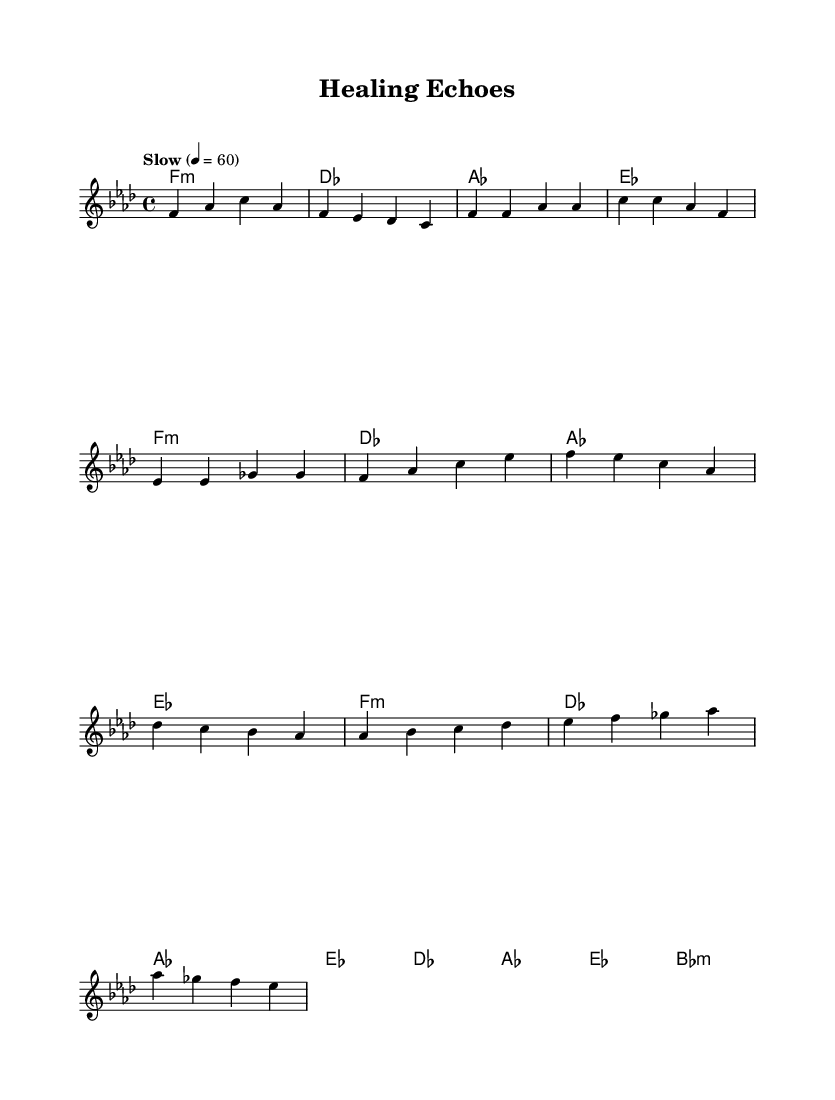What is the key signature of this music? The key signature is indicated by the key signature symbol on the staff. In this case, it is F minor, which has four flats (B, E, A, and D).
Answer: F minor What is the time signature of the piece? The time signature is shown at the beginning of the music; here, it is 4/4, meaning there are four beats per measure, and each quarter note receives one beat.
Answer: 4/4 What is the tempo marking for this piece? The tempo marking indicated at the start of the score says "Slow" and sets the beat at 60 beats per minute. This is a common way to denote a slower pace often found in ballads.
Answer: Slow, 60 How many measures are in the chorus section? By counting the measures in the chorus section of the music shown, we find that there are four measures dedicated to the chorus. This can be determined by identifying the grouping of the notes and their corresponding measures.
Answer: 4 What type of chord is indicated for the intro section? The intro section contains a chord label that indicates "F:min" at the beginning, showing it is a minor chord, which is often characteristic of the mood in soul music.
Answer: F:min What musical pattern is primarily used in the melody? The melody predominantly utilizes a simple repeating rhythmic pattern with quarter notes and can be seen in the first few measures. This reflects a common characteristic in soulful ballads, emphasizing emotional expression.
Answer: Repeating quarter notes What sentiment does the bridge convey through its chords? The bridge transitions use a series of chords (such as A♭, B♭, C, D♭) that create a contrast with the previous sections. This change often builds emotional tension, typical in soulful music, which addresses themes of trauma and resilience.
Answer: Emotional tension 